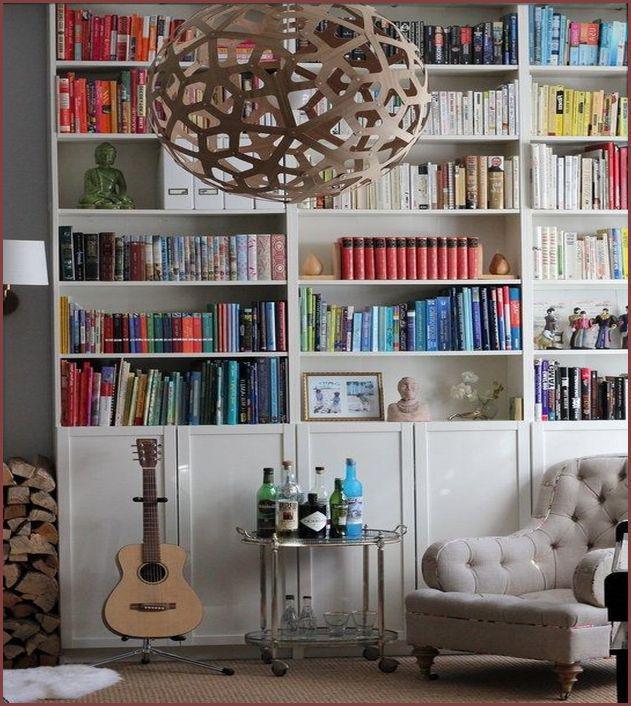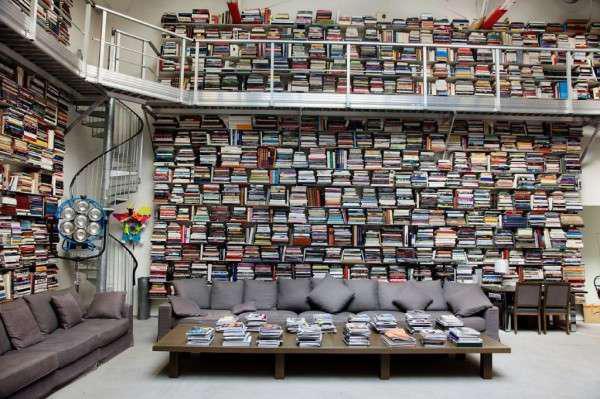The first image is the image on the left, the second image is the image on the right. For the images displayed, is the sentence "An image contains a large white bookshelf with an acoustic guitar on a stand in front of it." factually correct? Answer yes or no. Yes. 